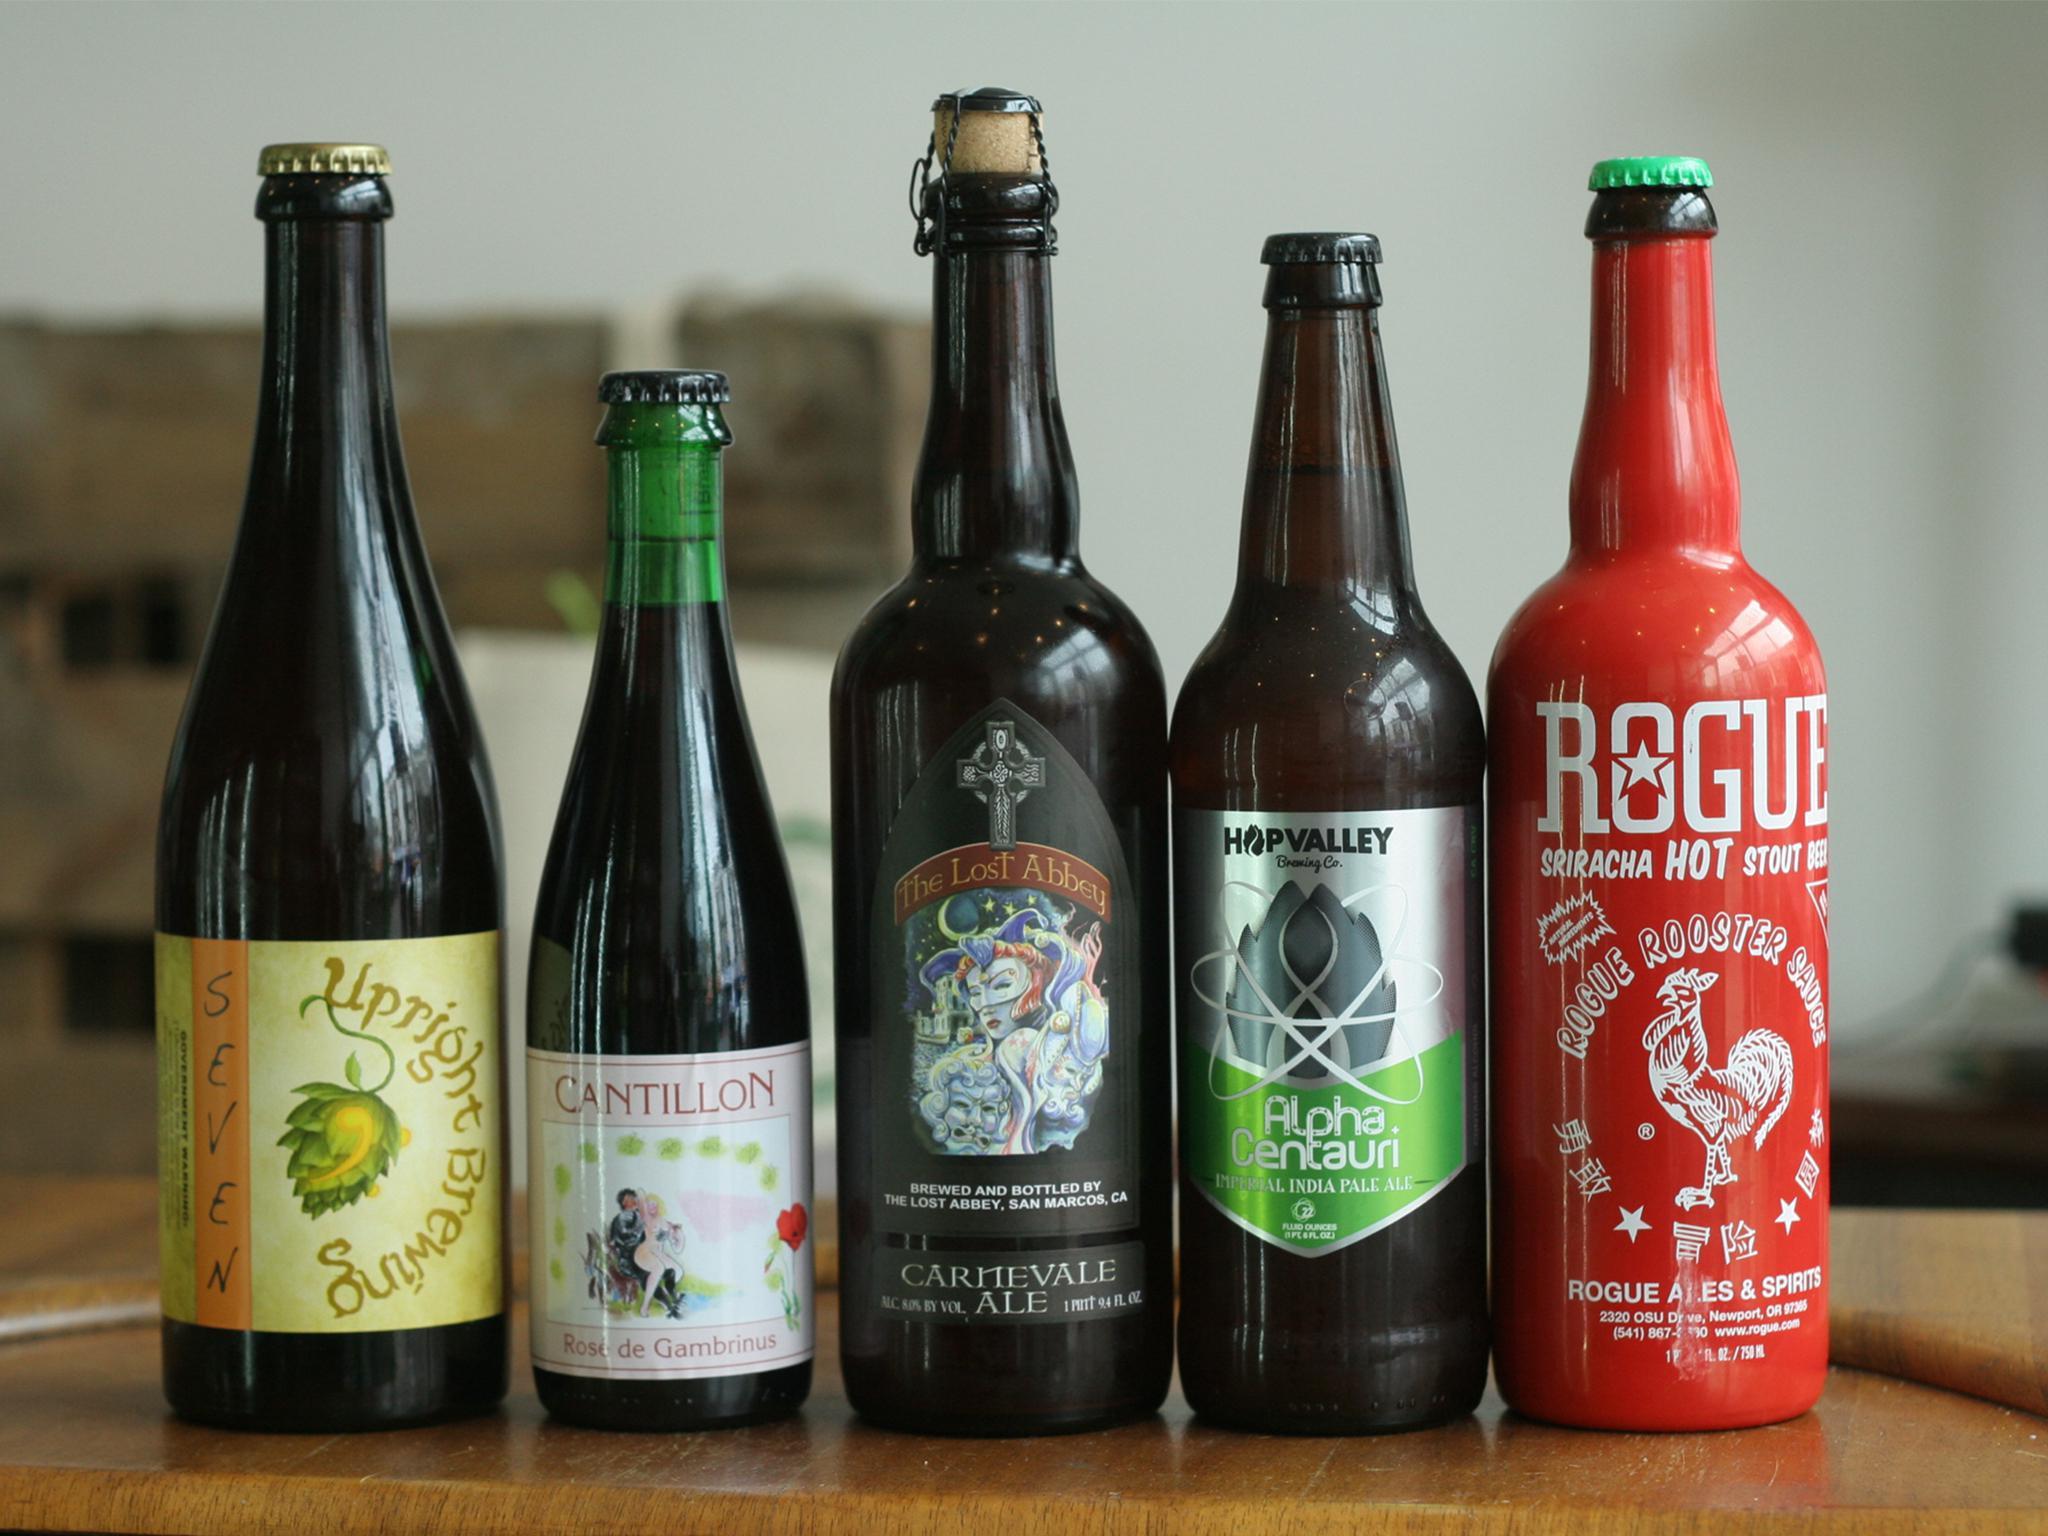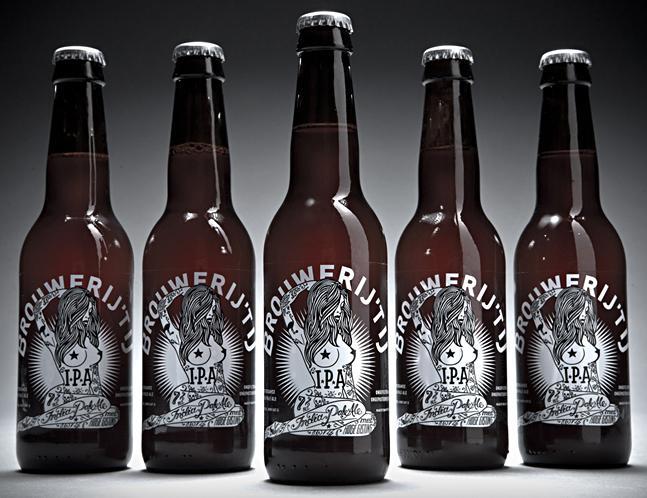The first image is the image on the left, the second image is the image on the right. Given the left and right images, does the statement "There are no more than six bottles in the image on the left" hold true? Answer yes or no. Yes. The first image is the image on the left, the second image is the image on the right. Considering the images on both sides, is "In one image, bottles of ale fill the shelf of a cooler." valid? Answer yes or no. No. 